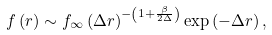<formula> <loc_0><loc_0><loc_500><loc_500>f \left ( r \right ) \sim f _ { \infty } \left ( \Delta r \right ) ^ { - \left ( 1 + \frac { \beta } { 2 \Delta } \right ) } \exp \left ( - \Delta r \right ) ,</formula> 